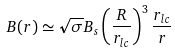<formula> <loc_0><loc_0><loc_500><loc_500>B ( r ) \simeq \sqrt { \sigma } B _ { s } \left ( \frac { R } { r _ { l c } } \right ) ^ { 3 } \frac { r _ { l c } } { r }</formula> 